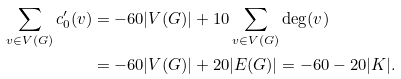Convert formula to latex. <formula><loc_0><loc_0><loc_500><loc_500>\sum _ { v \in V ( G ) } c ^ { \prime } _ { 0 } ( v ) & = - 6 0 | V ( G ) | + 1 0 \sum _ { v \in V ( G ) } \deg ( v ) \\ & = - 6 0 | V ( G ) | + 2 0 | E ( G ) | = - 6 0 - 2 0 | K | .</formula> 